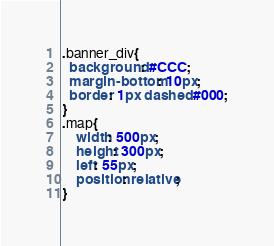Convert code to text. <code><loc_0><loc_0><loc_500><loc_500><_CSS_>.banner_div{
  background: #CCC;
  margin-bottom: 10px;
  border: 1px dashed #000;
}
.map{
    width: 500px;
    height: 300px;
    left: 55px;
    position: relative;
}
</code> 